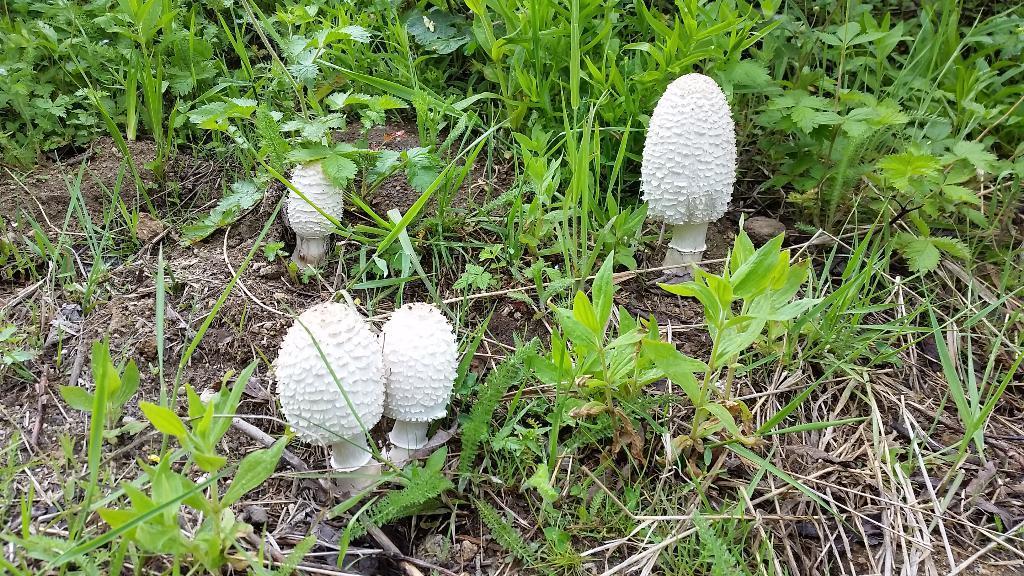Please provide a concise description of this image. In this picture we can see few mushrooms and plants. 